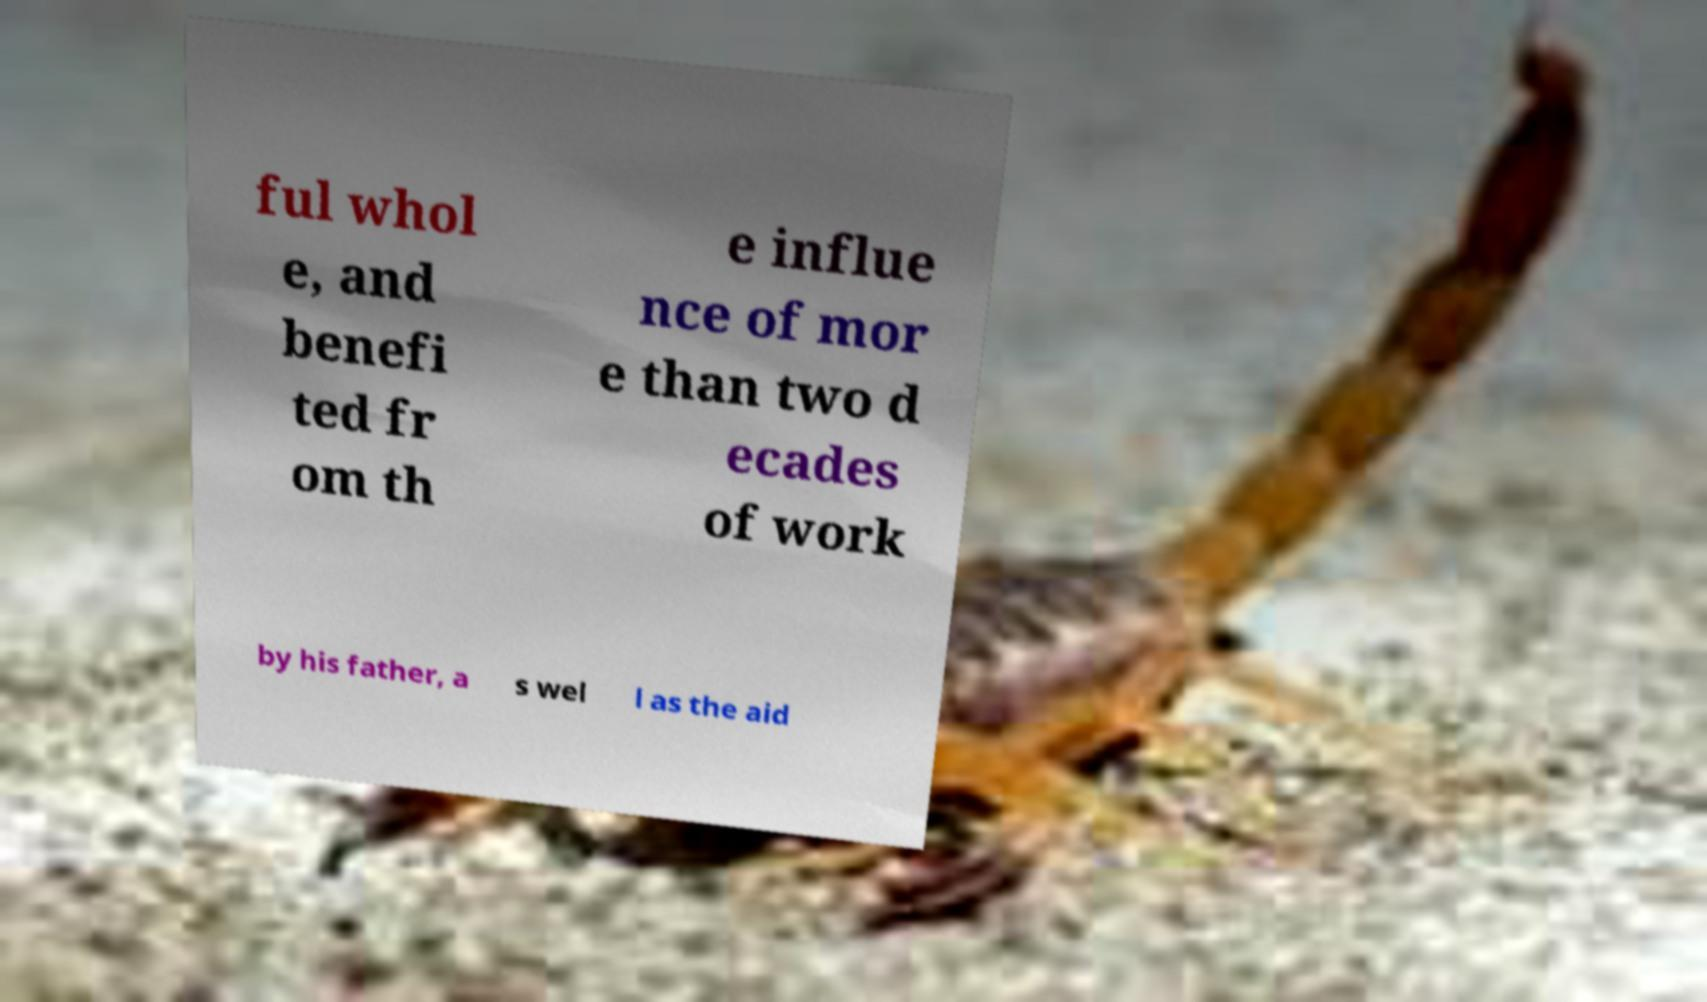Can you accurately transcribe the text from the provided image for me? ful whol e, and benefi ted fr om th e influe nce of mor e than two d ecades of work by his father, a s wel l as the aid 